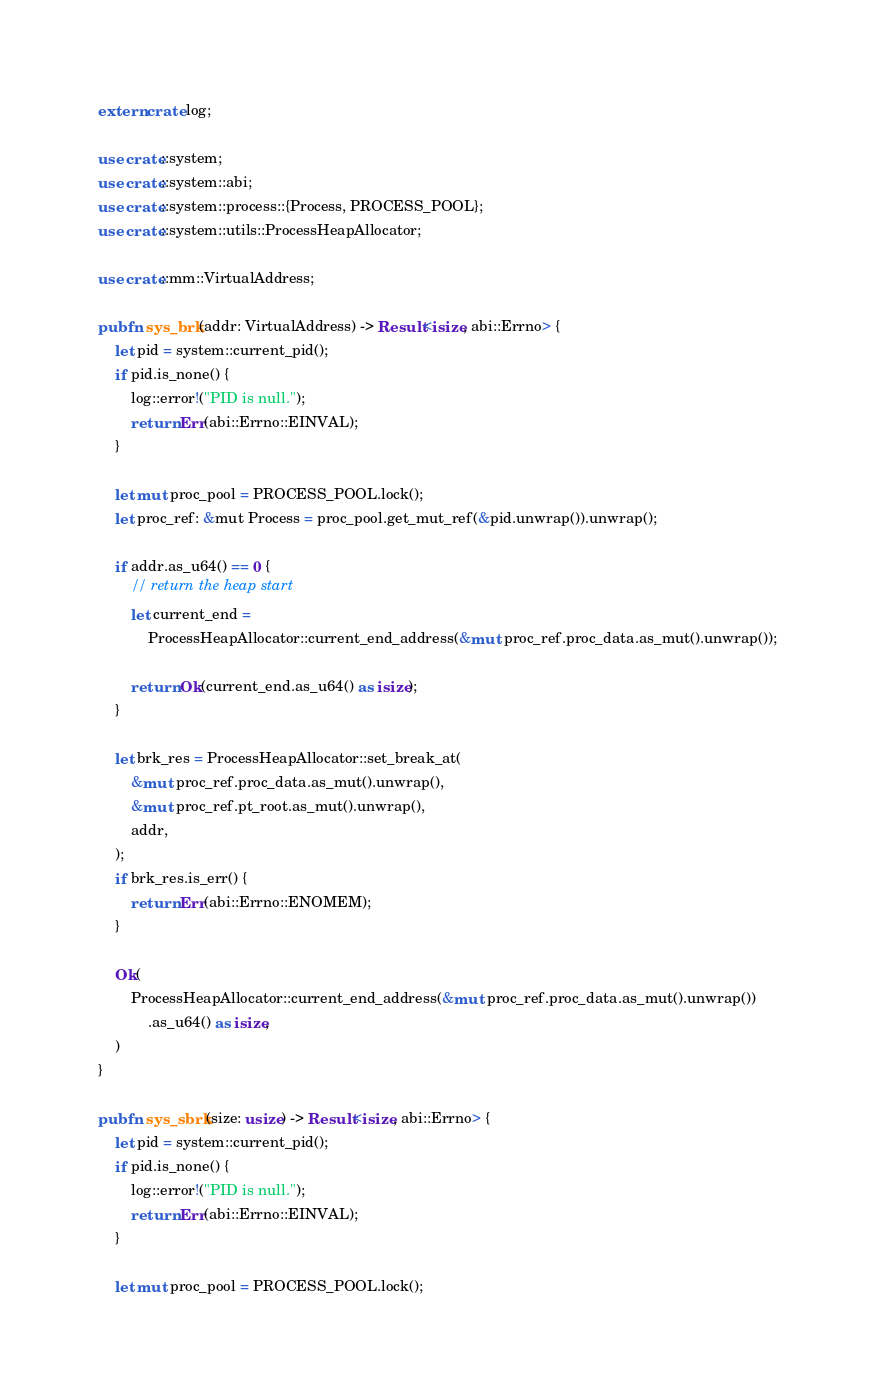<code> <loc_0><loc_0><loc_500><loc_500><_Rust_>extern crate log;

use crate::system;
use crate::system::abi;
use crate::system::process::{Process, PROCESS_POOL};
use crate::system::utils::ProcessHeapAllocator;

use crate::mm::VirtualAddress;

pub fn sys_brk(addr: VirtualAddress) -> Result<isize, abi::Errno> {
    let pid = system::current_pid();
    if pid.is_none() {
        log::error!("PID is null.");
        return Err(abi::Errno::EINVAL);
    }

    let mut proc_pool = PROCESS_POOL.lock();
    let proc_ref: &mut Process = proc_pool.get_mut_ref(&pid.unwrap()).unwrap();

    if addr.as_u64() == 0 {
        // return the heap start
        let current_end =
            ProcessHeapAllocator::current_end_address(&mut proc_ref.proc_data.as_mut().unwrap());

        return Ok(current_end.as_u64() as isize);
    }

    let brk_res = ProcessHeapAllocator::set_break_at(
        &mut proc_ref.proc_data.as_mut().unwrap(),
        &mut proc_ref.pt_root.as_mut().unwrap(),
        addr,
    );
    if brk_res.is_err() {
        return Err(abi::Errno::ENOMEM);
    }

    Ok(
        ProcessHeapAllocator::current_end_address(&mut proc_ref.proc_data.as_mut().unwrap())
            .as_u64() as isize,
    )
}

pub fn sys_sbrk(size: usize) -> Result<isize, abi::Errno> {
    let pid = system::current_pid();
    if pid.is_none() {
        log::error!("PID is null.");
        return Err(abi::Errno::EINVAL);
    }

    let mut proc_pool = PROCESS_POOL.lock();</code> 